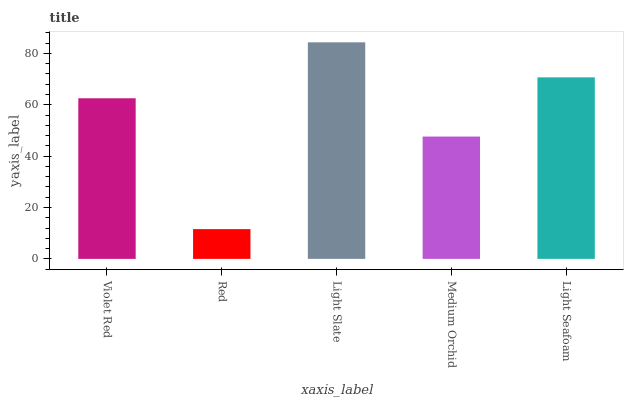Is Red the minimum?
Answer yes or no. Yes. Is Light Slate the maximum?
Answer yes or no. Yes. Is Light Slate the minimum?
Answer yes or no. No. Is Red the maximum?
Answer yes or no. No. Is Light Slate greater than Red?
Answer yes or no. Yes. Is Red less than Light Slate?
Answer yes or no. Yes. Is Red greater than Light Slate?
Answer yes or no. No. Is Light Slate less than Red?
Answer yes or no. No. Is Violet Red the high median?
Answer yes or no. Yes. Is Violet Red the low median?
Answer yes or no. Yes. Is Red the high median?
Answer yes or no. No. Is Red the low median?
Answer yes or no. No. 